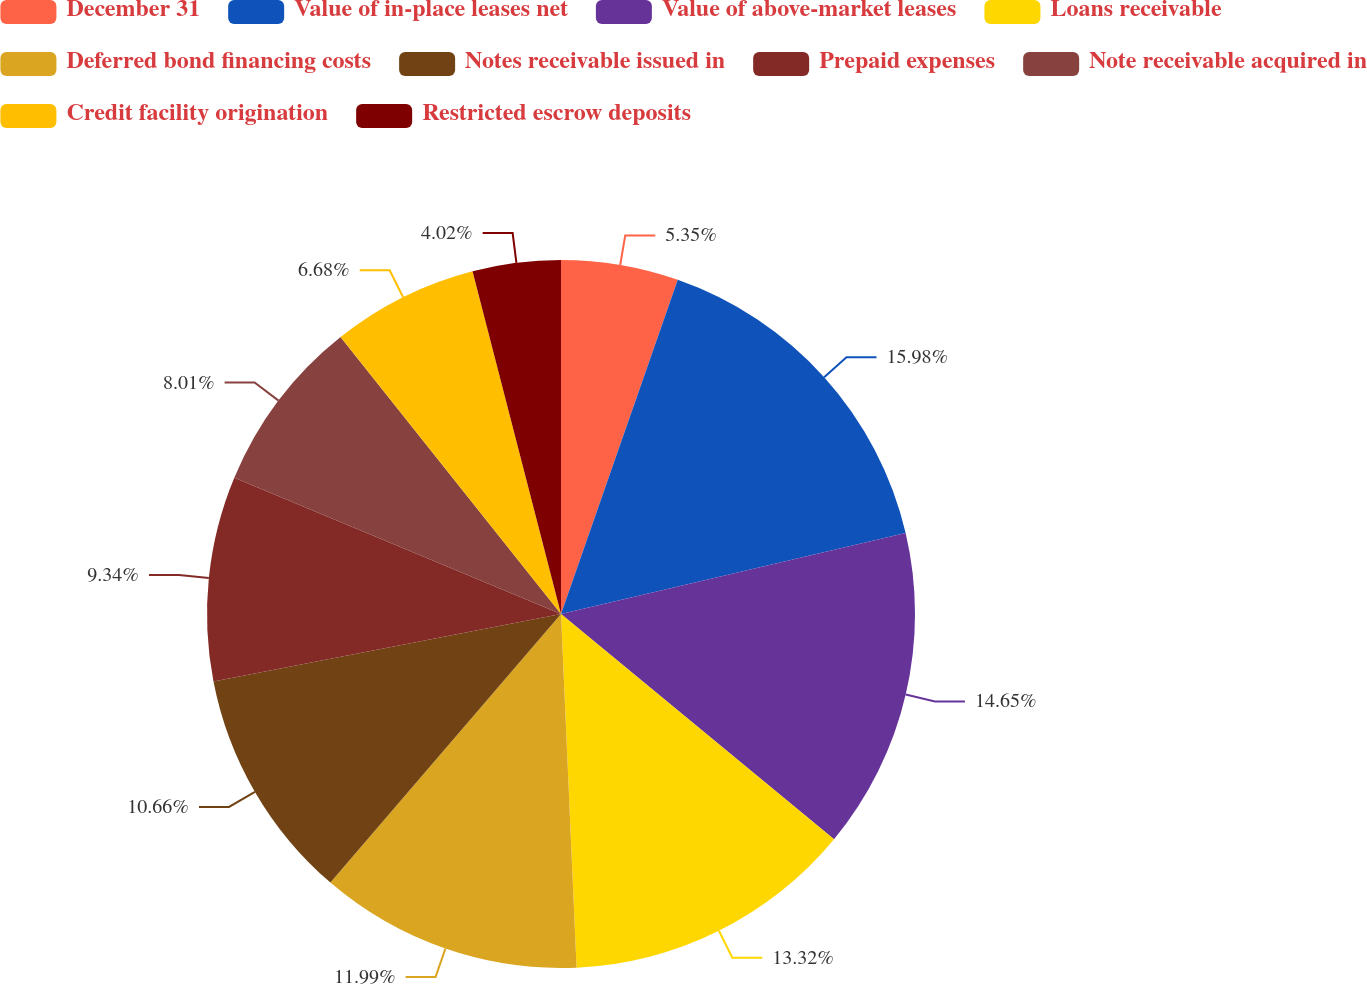<chart> <loc_0><loc_0><loc_500><loc_500><pie_chart><fcel>December 31<fcel>Value of in-place leases net<fcel>Value of above-market leases<fcel>Loans receivable<fcel>Deferred bond financing costs<fcel>Notes receivable issued in<fcel>Prepaid expenses<fcel>Note receivable acquired in<fcel>Credit facility origination<fcel>Restricted escrow deposits<nl><fcel>5.35%<fcel>15.98%<fcel>14.65%<fcel>13.32%<fcel>11.99%<fcel>10.66%<fcel>9.34%<fcel>8.01%<fcel>6.68%<fcel>4.02%<nl></chart> 